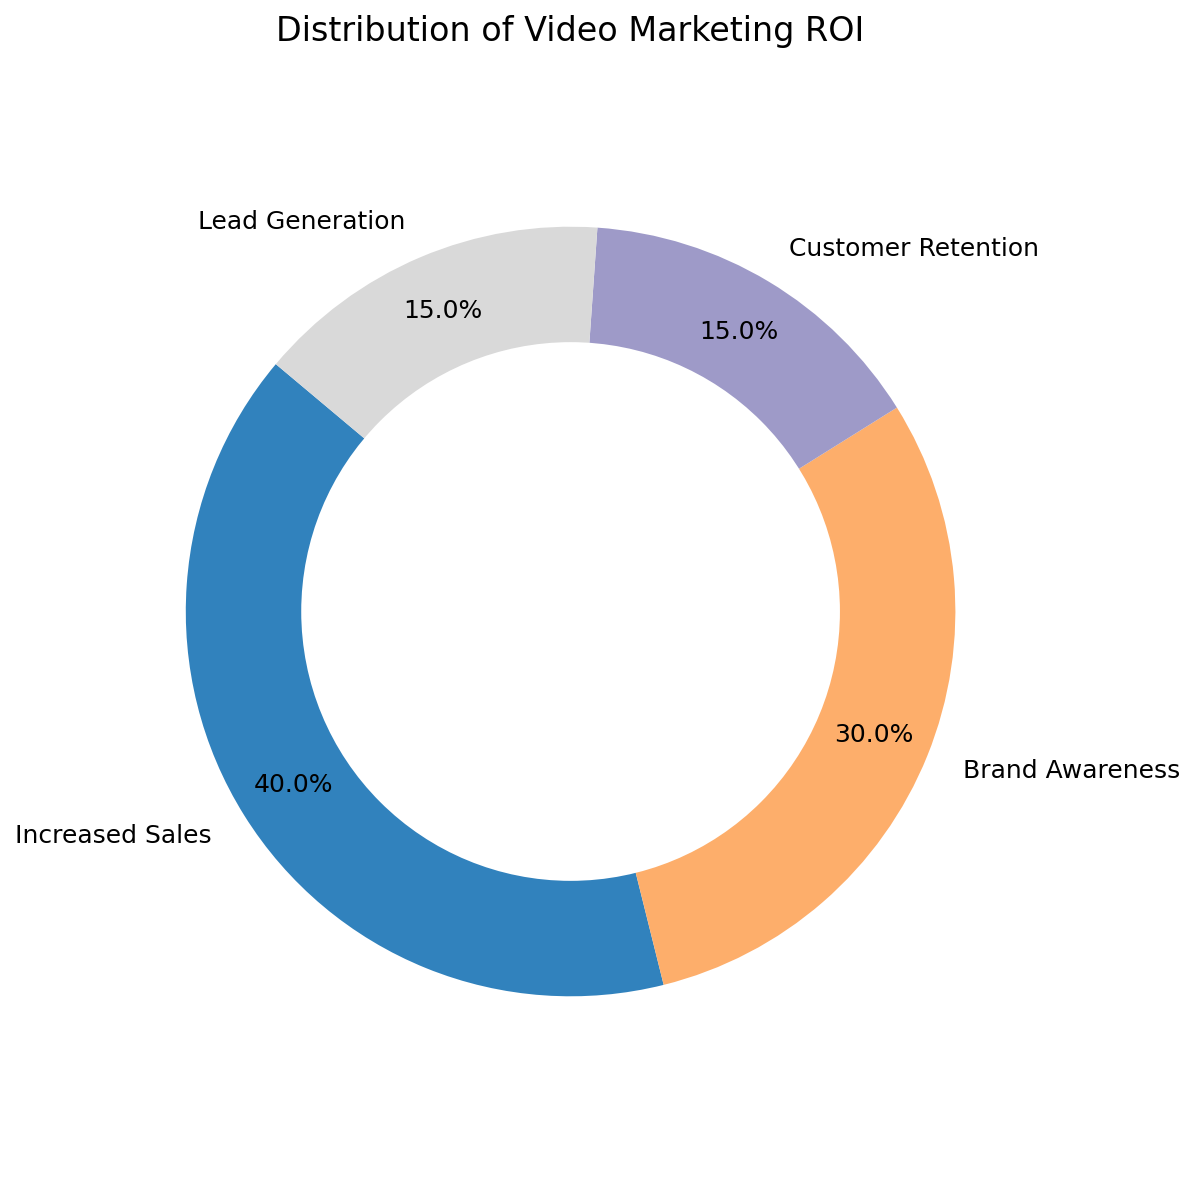What percentage of ROI is attributed to Increased Sales? Refer to the segment labeled "Increased Sales" in the pie chart; the percentage is given directly.
Answer: 40% What is the combined percentage of ROI attributed to Customer Retention and Lead Generation? Sum up the percentages for "Customer Retention" (15%) and "Lead Generation" (15%): 15% + 15% = 30%
Answer: 30% Which category contributes more to the ROI, Brand Awareness or Increased Sales? Compare the percentages for "Brand Awareness" (30%) and "Increased Sales" (40%): 40% is greater than 30%.
Answer: Increased Sales What is the difference in the ROI percentage between Brand Awareness and Customer Retention? Subtract the percentage of "Customer Retention" (15%) from "Brand Awareness" (30%): 30% - 15% = 15%
Answer: 15% How many categories contribute 15% each to the ROI? Identify the categories with 15% each: "Customer Retention" and "Lead Generation". There are 2 such categories.
Answer: 2 Which category has the second highest ROI contribution? Observe the pie chart. The category with the second highest percentage after "Increased Sales" (40%) is "Brand Awareness" (30%).
Answer: Brand Awareness What percentage of the ROI do Brand Awareness and Increased Sales together account for? Sum up the percentages for "Brand Awareness" (30%) and "Increased Sales" (40%): 30% + 40% = 70%
Answer: 70% Is the percentage of ROI attributed to Lead Generation equal to that of Customer Retention? Compare the percentages for "Lead Generation" (15%) and "Customer Retention" (15%): both are the same.
Answer: Yes Which color represents the Lead Generation segment? Look at the pie chart and identify the segment colored to match Lead Generation (usually after identifying the color in the legend or chart).
Answer: (Color description from the visual) 